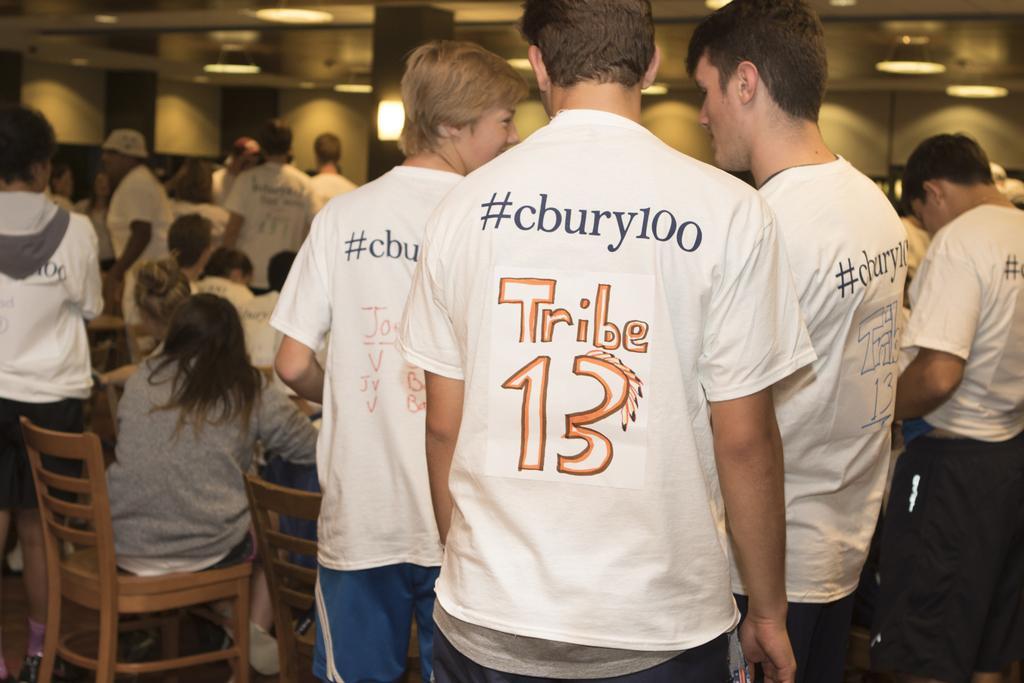Describe this image in one or two sentences. Most of the persons wore white t-shirt and standing. These persons are sitting on a chairs. On top there are lights. 